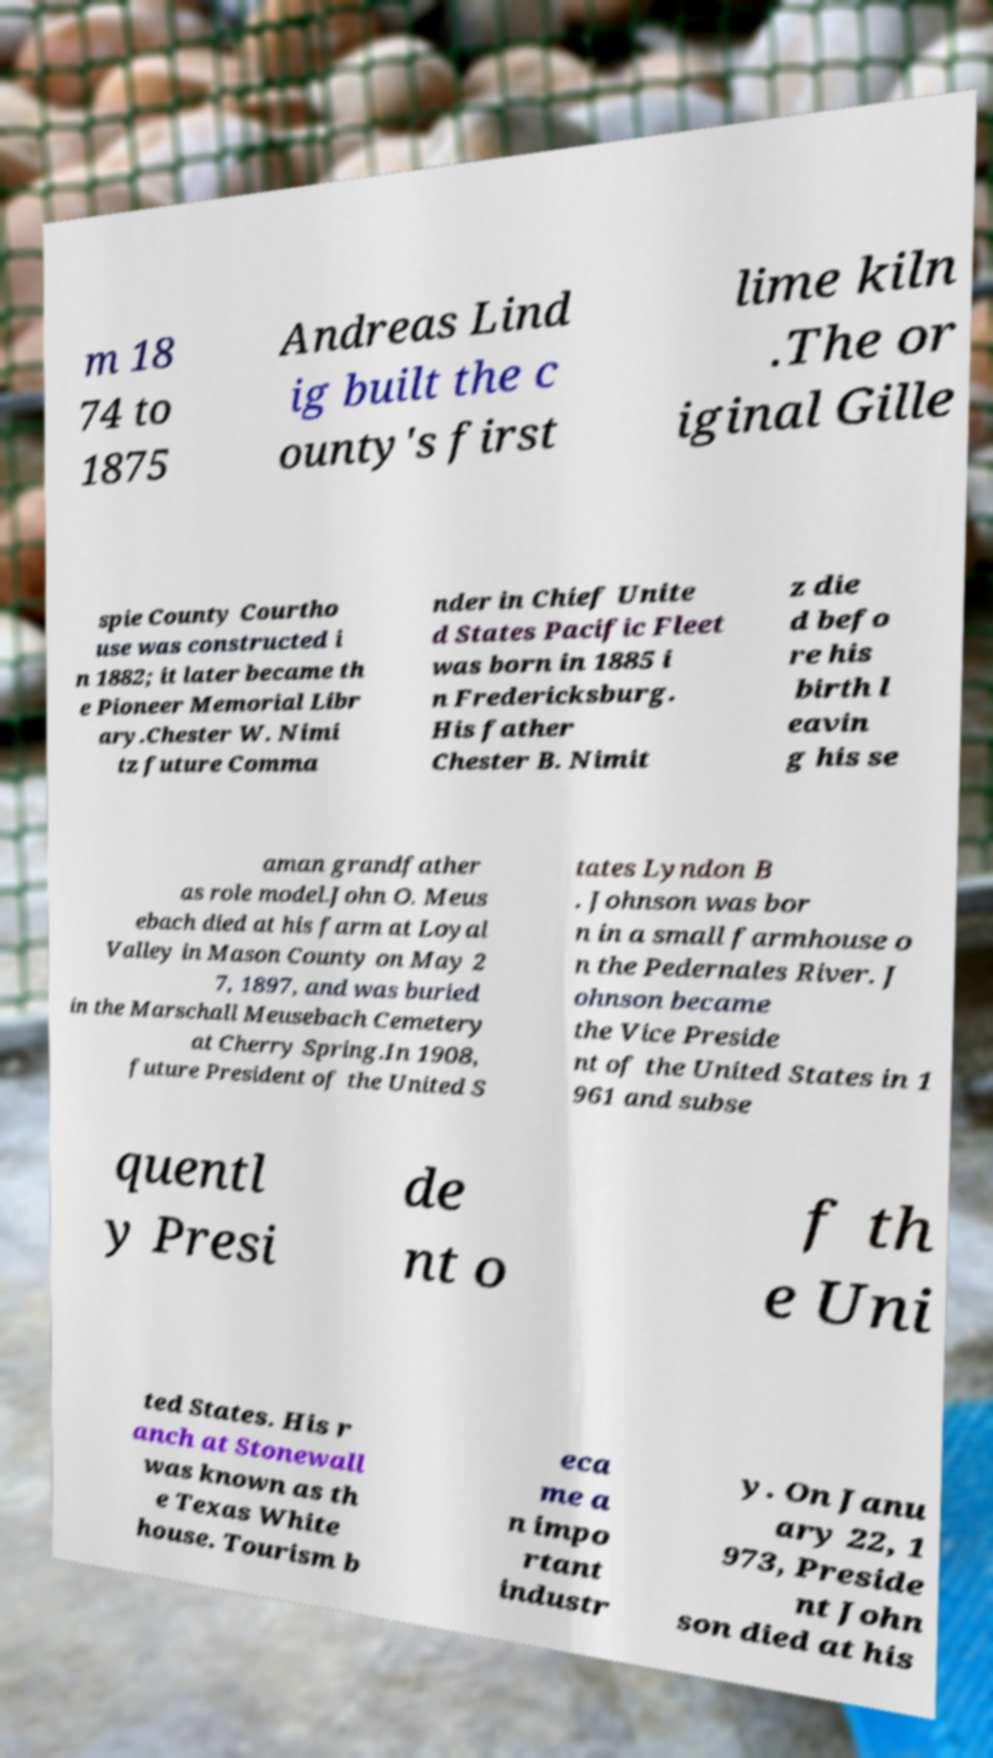Can you read and provide the text displayed in the image?This photo seems to have some interesting text. Can you extract and type it out for me? m 18 74 to 1875 Andreas Lind ig built the c ounty's first lime kiln .The or iginal Gille spie County Courtho use was constructed i n 1882; it later became th e Pioneer Memorial Libr ary.Chester W. Nimi tz future Comma nder in Chief Unite d States Pacific Fleet was born in 1885 i n Fredericksburg. His father Chester B. Nimit z die d befo re his birth l eavin g his se aman grandfather as role model.John O. Meus ebach died at his farm at Loyal Valley in Mason County on May 2 7, 1897, and was buried in the Marschall Meusebach Cemetery at Cherry Spring.In 1908, future President of the United S tates Lyndon B . Johnson was bor n in a small farmhouse o n the Pedernales River. J ohnson became the Vice Preside nt of the United States in 1 961 and subse quentl y Presi de nt o f th e Uni ted States. His r anch at Stonewall was known as th e Texas White house. Tourism b eca me a n impo rtant industr y. On Janu ary 22, 1 973, Preside nt John son died at his 